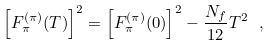Convert formula to latex. <formula><loc_0><loc_0><loc_500><loc_500>\left [ F _ { \pi } ^ { ( \pi ) } ( T ) \right ] ^ { 2 } = \left [ F _ { \pi } ^ { ( \pi ) } ( 0 ) \right ] ^ { 2 } - \frac { N _ { f } } { 1 2 } T ^ { 2 } \ ,</formula> 